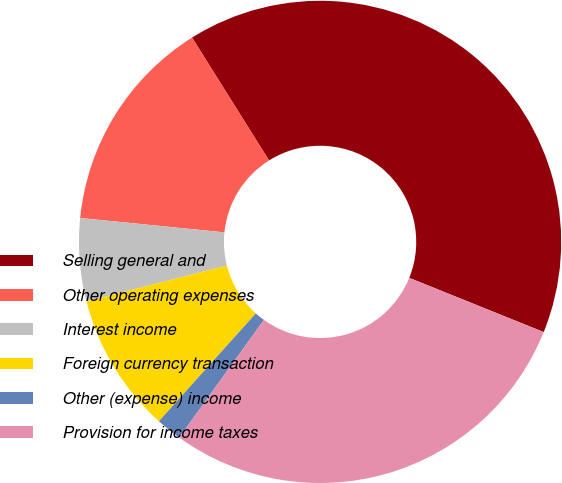<chart> <loc_0><loc_0><loc_500><loc_500><pie_chart><fcel>Selling general and<fcel>Other operating expenses<fcel>Interest income<fcel>Foreign currency transaction<fcel>Other (expense) income<fcel>Provision for income taxes<nl><fcel>40.01%<fcel>14.51%<fcel>5.55%<fcel>9.38%<fcel>1.72%<fcel>28.83%<nl></chart> 